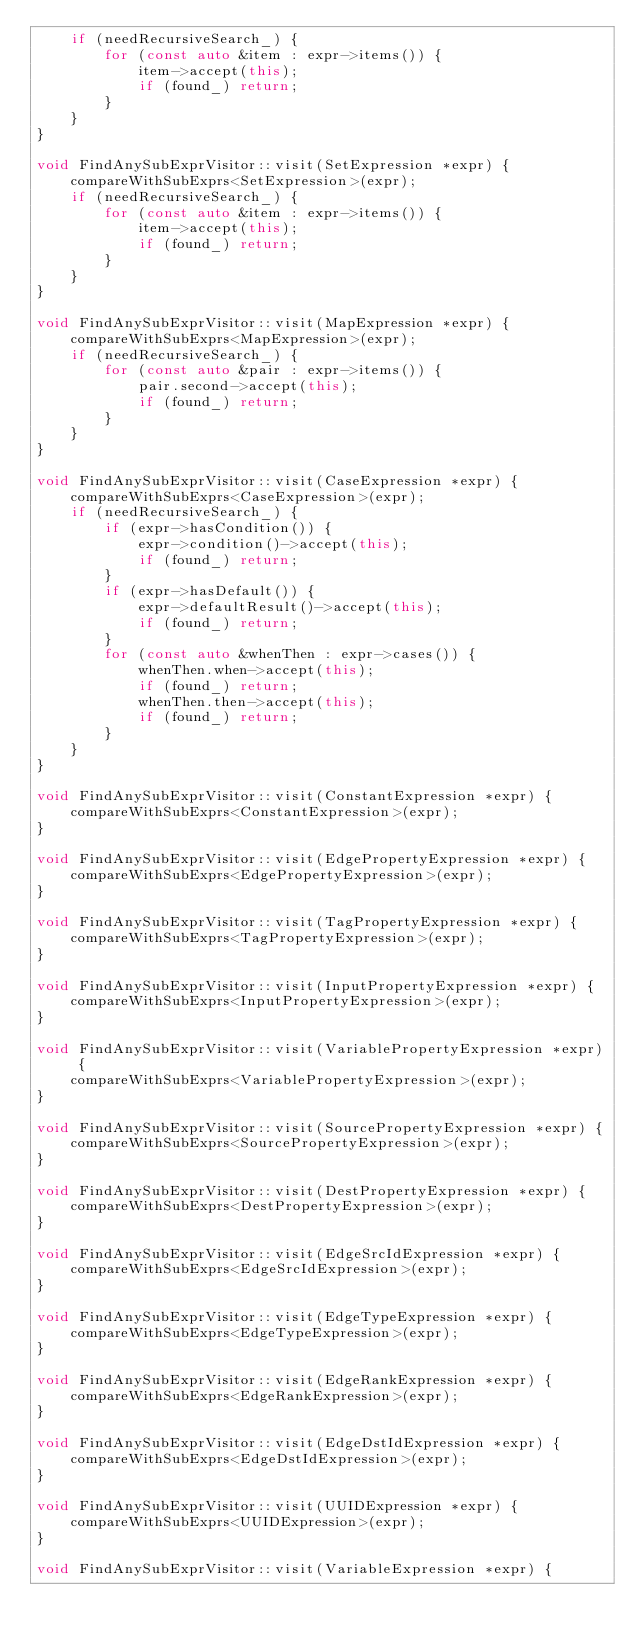<code> <loc_0><loc_0><loc_500><loc_500><_C++_>    if (needRecursiveSearch_) {
        for (const auto &item : expr->items()) {
            item->accept(this);
            if (found_) return;
        }
    }
}

void FindAnySubExprVisitor::visit(SetExpression *expr) {
    compareWithSubExprs<SetExpression>(expr);
    if (needRecursiveSearch_) {
        for (const auto &item : expr->items()) {
            item->accept(this);
            if (found_) return;
        }
    }
}

void FindAnySubExprVisitor::visit(MapExpression *expr) {
    compareWithSubExprs<MapExpression>(expr);
    if (needRecursiveSearch_) {
        for (const auto &pair : expr->items()) {
            pair.second->accept(this);
            if (found_) return;
        }
    }
}

void FindAnySubExprVisitor::visit(CaseExpression *expr) {
    compareWithSubExprs<CaseExpression>(expr);
    if (needRecursiveSearch_) {
        if (expr->hasCondition()) {
            expr->condition()->accept(this);
            if (found_) return;
        }
        if (expr->hasDefault()) {
            expr->defaultResult()->accept(this);
            if (found_) return;
        }
        for (const auto &whenThen : expr->cases()) {
            whenThen.when->accept(this);
            if (found_) return;
            whenThen.then->accept(this);
            if (found_) return;
        }
    }
}

void FindAnySubExprVisitor::visit(ConstantExpression *expr) {
    compareWithSubExprs<ConstantExpression>(expr);
}

void FindAnySubExprVisitor::visit(EdgePropertyExpression *expr) {
    compareWithSubExprs<EdgePropertyExpression>(expr);
}

void FindAnySubExprVisitor::visit(TagPropertyExpression *expr) {
    compareWithSubExprs<TagPropertyExpression>(expr);
}

void FindAnySubExprVisitor::visit(InputPropertyExpression *expr) {
    compareWithSubExprs<InputPropertyExpression>(expr);
}

void FindAnySubExprVisitor::visit(VariablePropertyExpression *expr) {
    compareWithSubExprs<VariablePropertyExpression>(expr);
}

void FindAnySubExprVisitor::visit(SourcePropertyExpression *expr) {
    compareWithSubExprs<SourcePropertyExpression>(expr);
}

void FindAnySubExprVisitor::visit(DestPropertyExpression *expr) {
    compareWithSubExprs<DestPropertyExpression>(expr);
}

void FindAnySubExprVisitor::visit(EdgeSrcIdExpression *expr) {
    compareWithSubExprs<EdgeSrcIdExpression>(expr);
}

void FindAnySubExprVisitor::visit(EdgeTypeExpression *expr) {
    compareWithSubExprs<EdgeTypeExpression>(expr);
}

void FindAnySubExprVisitor::visit(EdgeRankExpression *expr) {
    compareWithSubExprs<EdgeRankExpression>(expr);
}

void FindAnySubExprVisitor::visit(EdgeDstIdExpression *expr) {
    compareWithSubExprs<EdgeDstIdExpression>(expr);
}

void FindAnySubExprVisitor::visit(UUIDExpression *expr) {
    compareWithSubExprs<UUIDExpression>(expr);
}

void FindAnySubExprVisitor::visit(VariableExpression *expr) {</code> 